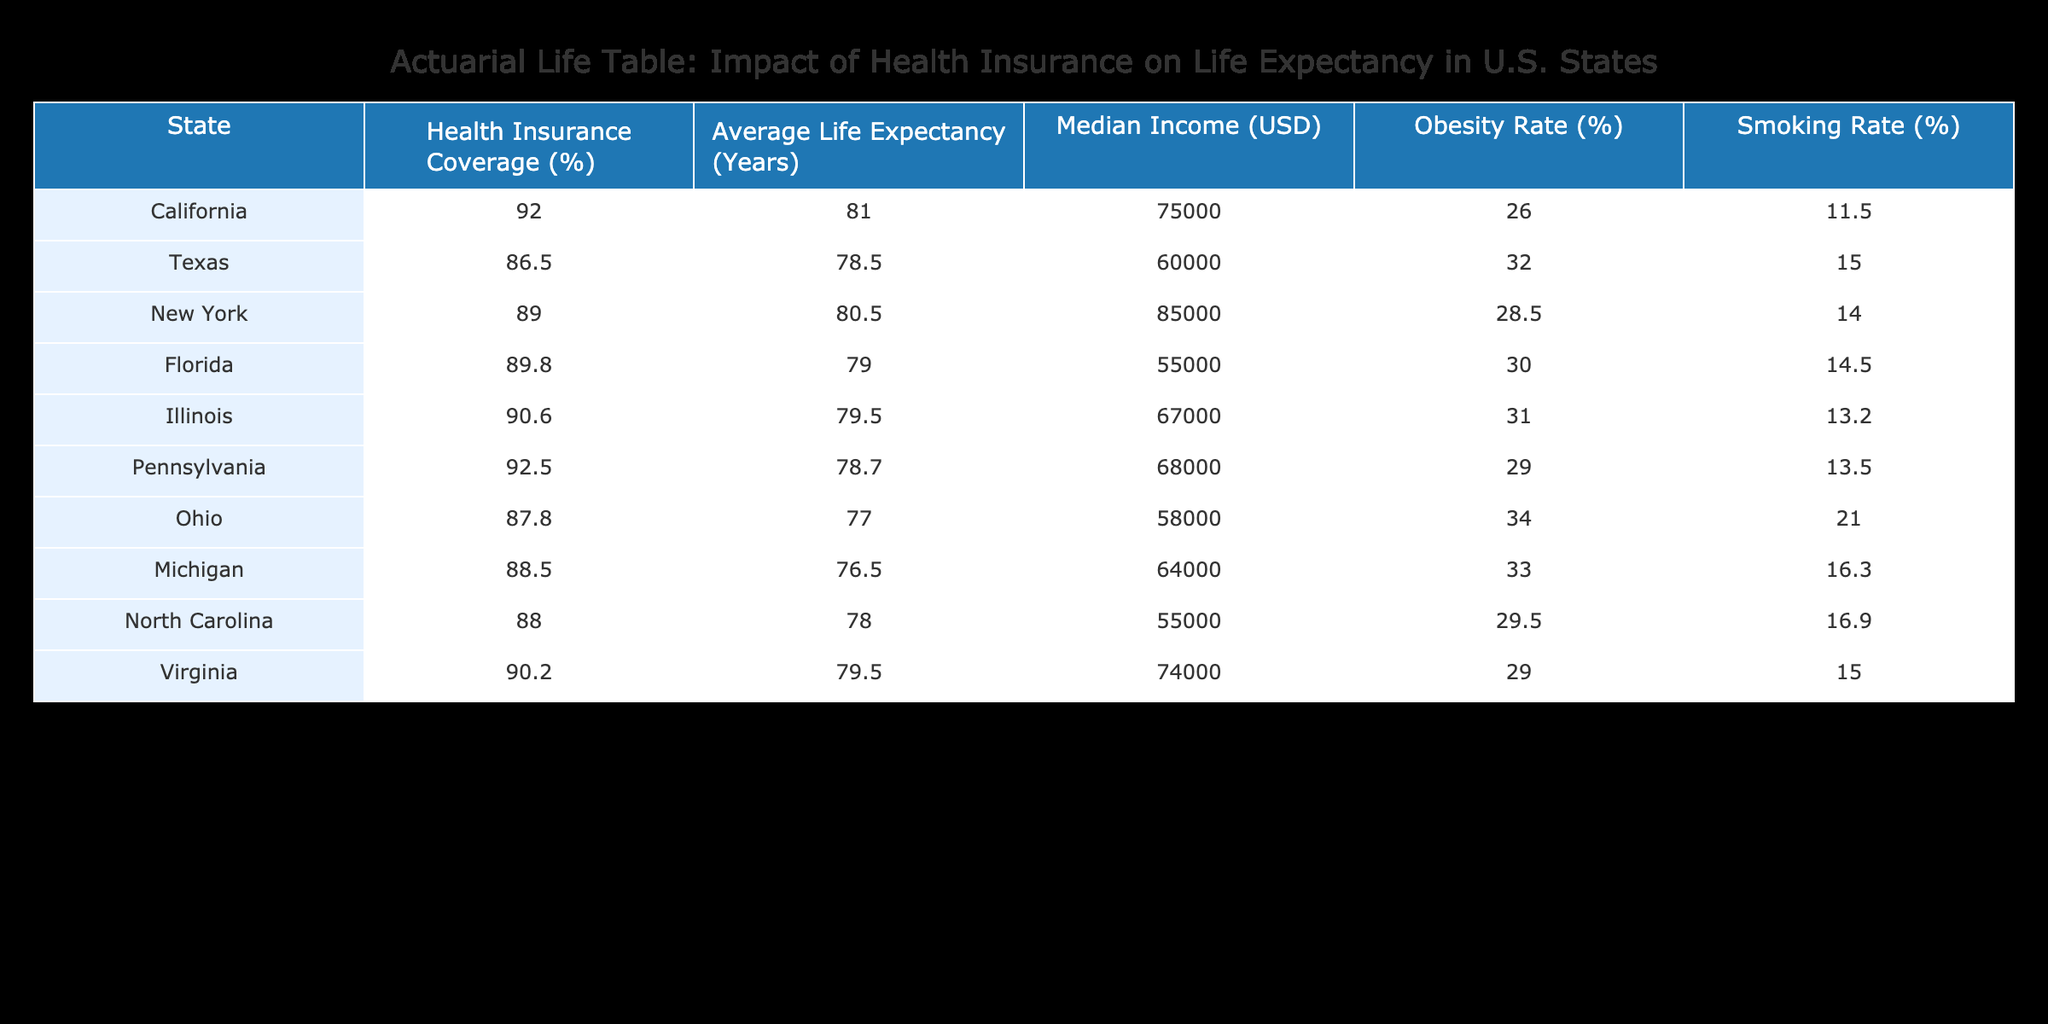What is the average life expectancy in California? According to the table, California's average life expectancy is listed as 81.0 years, which is directly pulled from the "Average Life Expectancy (Years)" column for California.
Answer: 81.0 Which state has the highest health insurance coverage? By checking the "Health Insurance Coverage (%)" column, I can see that Pennsylvania has the highest coverage at 92.5%.
Answer: Pennsylvania True or False: Ohio has a higher average life expectancy than Texas. From the table, Ohio's average life expectancy is 77.0 years, while Texas's is 78.5 years. Since 77.0 is not greater than 78.5, this statement is false.
Answer: False What is the difference in average life expectancy between the states with the highest and lowest obesity rates? The states with the highest obesity rate are Texas (32.0%) and Michigan (33.0%), and the state with the lowest obesity rate is California (26.0%). California's average life expectancy is 81.0 years, while Texas's is 78.5 years. The difference in life expectancy is 81.0 - 78.5 = 2.5 years.
Answer: 2.5 What is the median income of Florida compared to Illinois? Florida's median income is listed as 55000 USD and Illinois's is 67000 USD. To find the difference, we subtract Florida's median income from Illinois's: 67000 - 55000 = 12000 USD.
Answer: 12000 Which state has a lower smoking rate, Virginia or Florida? Looking at the "Smoking Rate (%)" column, Virginia has a smoking rate of 15.0%, while Florida has a smoking rate of 14.5%. Since 14.5% is lower than 15.0%, Florida has the lower smoking rate.
Answer: Florida What is the average life expectancy of states with more than 90% health insurance coverage? The states with more than 90% health insurance coverage are California (81.0), Illinois (79.5), and Pennsylvania (78.7). To find the average, add these values: 81.0 + 79.5 + 78.7 = 239.2, then divide by 3: 239.2 / 3 = 79.73 years.
Answer: 79.73 True or False: North Carolina has a higher median income than Texas. The median income for North Carolina is 55000 USD, and for Texas, it is 60000 USD. Since 55000 is less than 60000, the statement is false.
Answer: False What state shows the lowest health insurance coverage, and what is the percentage? By examining the "Health Insurance Coverage (%)" column, Texas has the lowest coverage at 86.5%.
Answer: Texas, 86.5% 